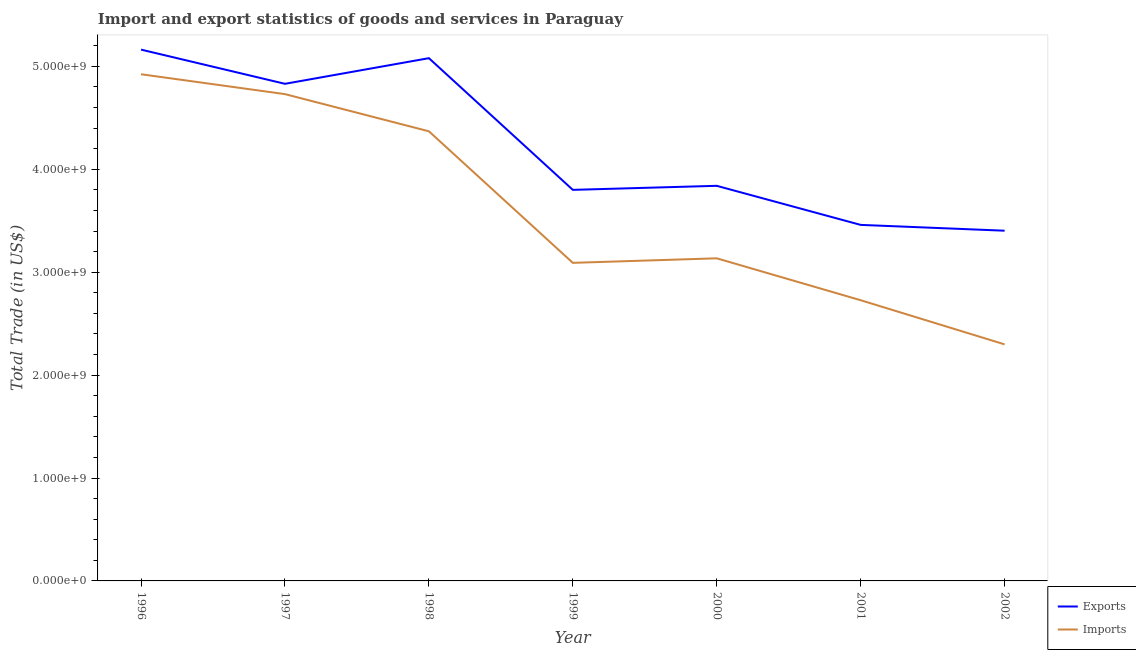How many different coloured lines are there?
Provide a succinct answer. 2. Does the line corresponding to imports of goods and services intersect with the line corresponding to export of goods and services?
Your answer should be compact. No. Is the number of lines equal to the number of legend labels?
Your answer should be compact. Yes. What is the imports of goods and services in 1998?
Offer a terse response. 4.37e+09. Across all years, what is the maximum imports of goods and services?
Make the answer very short. 4.92e+09. Across all years, what is the minimum export of goods and services?
Provide a succinct answer. 3.40e+09. In which year was the imports of goods and services maximum?
Your response must be concise. 1996. What is the total export of goods and services in the graph?
Your answer should be very brief. 2.96e+1. What is the difference between the export of goods and services in 1998 and that in 1999?
Your answer should be compact. 1.28e+09. What is the difference between the export of goods and services in 1998 and the imports of goods and services in 2002?
Offer a terse response. 2.78e+09. What is the average imports of goods and services per year?
Your response must be concise. 3.61e+09. In the year 1998, what is the difference between the imports of goods and services and export of goods and services?
Your response must be concise. -7.11e+08. In how many years, is the export of goods and services greater than 2800000000 US$?
Provide a succinct answer. 7. What is the ratio of the export of goods and services in 1999 to that in 2002?
Make the answer very short. 1.12. What is the difference between the highest and the second highest export of goods and services?
Your answer should be very brief. 8.31e+07. What is the difference between the highest and the lowest export of goods and services?
Provide a short and direct response. 1.76e+09. In how many years, is the export of goods and services greater than the average export of goods and services taken over all years?
Give a very brief answer. 3. Is the imports of goods and services strictly greater than the export of goods and services over the years?
Make the answer very short. No. Is the export of goods and services strictly less than the imports of goods and services over the years?
Offer a very short reply. No. How many years are there in the graph?
Offer a very short reply. 7. Does the graph contain any zero values?
Offer a very short reply. No. Does the graph contain grids?
Your answer should be very brief. No. What is the title of the graph?
Make the answer very short. Import and export statistics of goods and services in Paraguay. What is the label or title of the Y-axis?
Your response must be concise. Total Trade (in US$). What is the Total Trade (in US$) in Exports in 1996?
Keep it short and to the point. 5.16e+09. What is the Total Trade (in US$) in Imports in 1996?
Your answer should be very brief. 4.92e+09. What is the Total Trade (in US$) of Exports in 1997?
Offer a very short reply. 4.83e+09. What is the Total Trade (in US$) in Imports in 1997?
Give a very brief answer. 4.73e+09. What is the Total Trade (in US$) in Exports in 1998?
Ensure brevity in your answer.  5.08e+09. What is the Total Trade (in US$) of Imports in 1998?
Provide a succinct answer. 4.37e+09. What is the Total Trade (in US$) in Exports in 1999?
Your answer should be very brief. 3.80e+09. What is the Total Trade (in US$) in Imports in 1999?
Provide a short and direct response. 3.09e+09. What is the Total Trade (in US$) in Exports in 2000?
Offer a very short reply. 3.84e+09. What is the Total Trade (in US$) of Imports in 2000?
Your answer should be compact. 3.13e+09. What is the Total Trade (in US$) of Exports in 2001?
Your answer should be compact. 3.46e+09. What is the Total Trade (in US$) in Imports in 2001?
Offer a very short reply. 2.73e+09. What is the Total Trade (in US$) of Exports in 2002?
Offer a very short reply. 3.40e+09. What is the Total Trade (in US$) of Imports in 2002?
Give a very brief answer. 2.30e+09. Across all years, what is the maximum Total Trade (in US$) of Exports?
Offer a terse response. 5.16e+09. Across all years, what is the maximum Total Trade (in US$) of Imports?
Give a very brief answer. 4.92e+09. Across all years, what is the minimum Total Trade (in US$) of Exports?
Offer a terse response. 3.40e+09. Across all years, what is the minimum Total Trade (in US$) in Imports?
Your answer should be very brief. 2.30e+09. What is the total Total Trade (in US$) of Exports in the graph?
Your answer should be compact. 2.96e+1. What is the total Total Trade (in US$) in Imports in the graph?
Keep it short and to the point. 2.53e+1. What is the difference between the Total Trade (in US$) in Exports in 1996 and that in 1997?
Your answer should be very brief. 3.32e+08. What is the difference between the Total Trade (in US$) in Imports in 1996 and that in 1997?
Give a very brief answer. 1.93e+08. What is the difference between the Total Trade (in US$) in Exports in 1996 and that in 1998?
Offer a terse response. 8.31e+07. What is the difference between the Total Trade (in US$) in Imports in 1996 and that in 1998?
Your response must be concise. 5.54e+08. What is the difference between the Total Trade (in US$) in Exports in 1996 and that in 1999?
Provide a succinct answer. 1.36e+09. What is the difference between the Total Trade (in US$) of Imports in 1996 and that in 1999?
Your answer should be very brief. 1.83e+09. What is the difference between the Total Trade (in US$) of Exports in 1996 and that in 2000?
Keep it short and to the point. 1.32e+09. What is the difference between the Total Trade (in US$) of Imports in 1996 and that in 2000?
Provide a succinct answer. 1.79e+09. What is the difference between the Total Trade (in US$) in Exports in 1996 and that in 2001?
Give a very brief answer. 1.70e+09. What is the difference between the Total Trade (in US$) of Imports in 1996 and that in 2001?
Offer a very short reply. 2.20e+09. What is the difference between the Total Trade (in US$) of Exports in 1996 and that in 2002?
Give a very brief answer. 1.76e+09. What is the difference between the Total Trade (in US$) in Imports in 1996 and that in 2002?
Give a very brief answer. 2.62e+09. What is the difference between the Total Trade (in US$) of Exports in 1997 and that in 1998?
Offer a very short reply. -2.49e+08. What is the difference between the Total Trade (in US$) in Imports in 1997 and that in 1998?
Ensure brevity in your answer.  3.61e+08. What is the difference between the Total Trade (in US$) in Exports in 1997 and that in 1999?
Your answer should be compact. 1.03e+09. What is the difference between the Total Trade (in US$) of Imports in 1997 and that in 1999?
Your response must be concise. 1.64e+09. What is the difference between the Total Trade (in US$) in Exports in 1997 and that in 2000?
Make the answer very short. 9.91e+08. What is the difference between the Total Trade (in US$) in Imports in 1997 and that in 2000?
Your response must be concise. 1.60e+09. What is the difference between the Total Trade (in US$) of Exports in 1997 and that in 2001?
Keep it short and to the point. 1.37e+09. What is the difference between the Total Trade (in US$) of Imports in 1997 and that in 2001?
Make the answer very short. 2.00e+09. What is the difference between the Total Trade (in US$) of Exports in 1997 and that in 2002?
Your answer should be compact. 1.43e+09. What is the difference between the Total Trade (in US$) of Imports in 1997 and that in 2002?
Ensure brevity in your answer.  2.43e+09. What is the difference between the Total Trade (in US$) of Exports in 1998 and that in 1999?
Your response must be concise. 1.28e+09. What is the difference between the Total Trade (in US$) in Imports in 1998 and that in 1999?
Your answer should be very brief. 1.28e+09. What is the difference between the Total Trade (in US$) of Exports in 1998 and that in 2000?
Keep it short and to the point. 1.24e+09. What is the difference between the Total Trade (in US$) of Imports in 1998 and that in 2000?
Keep it short and to the point. 1.23e+09. What is the difference between the Total Trade (in US$) of Exports in 1998 and that in 2001?
Offer a terse response. 1.62e+09. What is the difference between the Total Trade (in US$) of Imports in 1998 and that in 2001?
Offer a very short reply. 1.64e+09. What is the difference between the Total Trade (in US$) in Exports in 1998 and that in 2002?
Keep it short and to the point. 1.68e+09. What is the difference between the Total Trade (in US$) in Imports in 1998 and that in 2002?
Offer a terse response. 2.07e+09. What is the difference between the Total Trade (in US$) in Exports in 1999 and that in 2000?
Your response must be concise. -3.92e+07. What is the difference between the Total Trade (in US$) of Imports in 1999 and that in 2000?
Your response must be concise. -4.40e+07. What is the difference between the Total Trade (in US$) of Exports in 1999 and that in 2001?
Offer a terse response. 3.40e+08. What is the difference between the Total Trade (in US$) in Imports in 1999 and that in 2001?
Provide a succinct answer. 3.63e+08. What is the difference between the Total Trade (in US$) of Exports in 1999 and that in 2002?
Make the answer very short. 3.97e+08. What is the difference between the Total Trade (in US$) of Imports in 1999 and that in 2002?
Ensure brevity in your answer.  7.92e+08. What is the difference between the Total Trade (in US$) in Exports in 2000 and that in 2001?
Provide a succinct answer. 3.80e+08. What is the difference between the Total Trade (in US$) in Imports in 2000 and that in 2001?
Provide a succinct answer. 4.07e+08. What is the difference between the Total Trade (in US$) in Exports in 2000 and that in 2002?
Offer a very short reply. 4.36e+08. What is the difference between the Total Trade (in US$) of Imports in 2000 and that in 2002?
Offer a terse response. 8.36e+08. What is the difference between the Total Trade (in US$) of Exports in 2001 and that in 2002?
Provide a succinct answer. 5.65e+07. What is the difference between the Total Trade (in US$) in Imports in 2001 and that in 2002?
Your answer should be very brief. 4.29e+08. What is the difference between the Total Trade (in US$) of Exports in 1996 and the Total Trade (in US$) of Imports in 1997?
Provide a succinct answer. 4.32e+08. What is the difference between the Total Trade (in US$) in Exports in 1996 and the Total Trade (in US$) in Imports in 1998?
Give a very brief answer. 7.94e+08. What is the difference between the Total Trade (in US$) of Exports in 1996 and the Total Trade (in US$) of Imports in 1999?
Keep it short and to the point. 2.07e+09. What is the difference between the Total Trade (in US$) of Exports in 1996 and the Total Trade (in US$) of Imports in 2000?
Your answer should be very brief. 2.03e+09. What is the difference between the Total Trade (in US$) of Exports in 1996 and the Total Trade (in US$) of Imports in 2001?
Offer a very short reply. 2.44e+09. What is the difference between the Total Trade (in US$) in Exports in 1996 and the Total Trade (in US$) in Imports in 2002?
Offer a very short reply. 2.86e+09. What is the difference between the Total Trade (in US$) in Exports in 1997 and the Total Trade (in US$) in Imports in 1998?
Provide a succinct answer. 4.61e+08. What is the difference between the Total Trade (in US$) in Exports in 1997 and the Total Trade (in US$) in Imports in 1999?
Provide a succinct answer. 1.74e+09. What is the difference between the Total Trade (in US$) of Exports in 1997 and the Total Trade (in US$) of Imports in 2000?
Offer a very short reply. 1.70e+09. What is the difference between the Total Trade (in US$) in Exports in 1997 and the Total Trade (in US$) in Imports in 2001?
Offer a terse response. 2.10e+09. What is the difference between the Total Trade (in US$) of Exports in 1997 and the Total Trade (in US$) of Imports in 2002?
Keep it short and to the point. 2.53e+09. What is the difference between the Total Trade (in US$) in Exports in 1998 and the Total Trade (in US$) in Imports in 1999?
Offer a terse response. 1.99e+09. What is the difference between the Total Trade (in US$) of Exports in 1998 and the Total Trade (in US$) of Imports in 2000?
Give a very brief answer. 1.94e+09. What is the difference between the Total Trade (in US$) in Exports in 1998 and the Total Trade (in US$) in Imports in 2001?
Keep it short and to the point. 2.35e+09. What is the difference between the Total Trade (in US$) of Exports in 1998 and the Total Trade (in US$) of Imports in 2002?
Offer a very short reply. 2.78e+09. What is the difference between the Total Trade (in US$) of Exports in 1999 and the Total Trade (in US$) of Imports in 2000?
Give a very brief answer. 6.65e+08. What is the difference between the Total Trade (in US$) in Exports in 1999 and the Total Trade (in US$) in Imports in 2001?
Ensure brevity in your answer.  1.07e+09. What is the difference between the Total Trade (in US$) of Exports in 1999 and the Total Trade (in US$) of Imports in 2002?
Ensure brevity in your answer.  1.50e+09. What is the difference between the Total Trade (in US$) in Exports in 2000 and the Total Trade (in US$) in Imports in 2001?
Your answer should be very brief. 1.11e+09. What is the difference between the Total Trade (in US$) of Exports in 2000 and the Total Trade (in US$) of Imports in 2002?
Offer a very short reply. 1.54e+09. What is the difference between the Total Trade (in US$) in Exports in 2001 and the Total Trade (in US$) in Imports in 2002?
Offer a terse response. 1.16e+09. What is the average Total Trade (in US$) of Exports per year?
Your response must be concise. 4.22e+09. What is the average Total Trade (in US$) of Imports per year?
Offer a terse response. 3.61e+09. In the year 1996, what is the difference between the Total Trade (in US$) in Exports and Total Trade (in US$) in Imports?
Provide a short and direct response. 2.39e+08. In the year 1997, what is the difference between the Total Trade (in US$) in Exports and Total Trade (in US$) in Imports?
Ensure brevity in your answer.  1.00e+08. In the year 1998, what is the difference between the Total Trade (in US$) of Exports and Total Trade (in US$) of Imports?
Your answer should be very brief. 7.11e+08. In the year 1999, what is the difference between the Total Trade (in US$) in Exports and Total Trade (in US$) in Imports?
Offer a terse response. 7.09e+08. In the year 2000, what is the difference between the Total Trade (in US$) in Exports and Total Trade (in US$) in Imports?
Give a very brief answer. 7.04e+08. In the year 2001, what is the difference between the Total Trade (in US$) of Exports and Total Trade (in US$) of Imports?
Your answer should be compact. 7.32e+08. In the year 2002, what is the difference between the Total Trade (in US$) in Exports and Total Trade (in US$) in Imports?
Ensure brevity in your answer.  1.10e+09. What is the ratio of the Total Trade (in US$) of Exports in 1996 to that in 1997?
Your answer should be very brief. 1.07. What is the ratio of the Total Trade (in US$) of Imports in 1996 to that in 1997?
Your answer should be very brief. 1.04. What is the ratio of the Total Trade (in US$) in Exports in 1996 to that in 1998?
Provide a succinct answer. 1.02. What is the ratio of the Total Trade (in US$) of Imports in 1996 to that in 1998?
Your answer should be compact. 1.13. What is the ratio of the Total Trade (in US$) of Exports in 1996 to that in 1999?
Your response must be concise. 1.36. What is the ratio of the Total Trade (in US$) of Imports in 1996 to that in 1999?
Your answer should be compact. 1.59. What is the ratio of the Total Trade (in US$) in Exports in 1996 to that in 2000?
Ensure brevity in your answer.  1.34. What is the ratio of the Total Trade (in US$) in Imports in 1996 to that in 2000?
Your answer should be compact. 1.57. What is the ratio of the Total Trade (in US$) in Exports in 1996 to that in 2001?
Keep it short and to the point. 1.49. What is the ratio of the Total Trade (in US$) in Imports in 1996 to that in 2001?
Keep it short and to the point. 1.81. What is the ratio of the Total Trade (in US$) in Exports in 1996 to that in 2002?
Offer a very short reply. 1.52. What is the ratio of the Total Trade (in US$) of Imports in 1996 to that in 2002?
Provide a short and direct response. 2.14. What is the ratio of the Total Trade (in US$) of Exports in 1997 to that in 1998?
Ensure brevity in your answer.  0.95. What is the ratio of the Total Trade (in US$) in Imports in 1997 to that in 1998?
Provide a short and direct response. 1.08. What is the ratio of the Total Trade (in US$) of Exports in 1997 to that in 1999?
Make the answer very short. 1.27. What is the ratio of the Total Trade (in US$) in Imports in 1997 to that in 1999?
Your answer should be compact. 1.53. What is the ratio of the Total Trade (in US$) of Exports in 1997 to that in 2000?
Provide a succinct answer. 1.26. What is the ratio of the Total Trade (in US$) of Imports in 1997 to that in 2000?
Make the answer very short. 1.51. What is the ratio of the Total Trade (in US$) of Exports in 1997 to that in 2001?
Your answer should be very brief. 1.4. What is the ratio of the Total Trade (in US$) of Imports in 1997 to that in 2001?
Keep it short and to the point. 1.73. What is the ratio of the Total Trade (in US$) of Exports in 1997 to that in 2002?
Provide a short and direct response. 1.42. What is the ratio of the Total Trade (in US$) in Imports in 1997 to that in 2002?
Your answer should be compact. 2.06. What is the ratio of the Total Trade (in US$) of Exports in 1998 to that in 1999?
Your response must be concise. 1.34. What is the ratio of the Total Trade (in US$) in Imports in 1998 to that in 1999?
Give a very brief answer. 1.41. What is the ratio of the Total Trade (in US$) in Exports in 1998 to that in 2000?
Offer a very short reply. 1.32. What is the ratio of the Total Trade (in US$) in Imports in 1998 to that in 2000?
Your response must be concise. 1.39. What is the ratio of the Total Trade (in US$) in Exports in 1998 to that in 2001?
Provide a succinct answer. 1.47. What is the ratio of the Total Trade (in US$) in Imports in 1998 to that in 2001?
Offer a terse response. 1.6. What is the ratio of the Total Trade (in US$) in Exports in 1998 to that in 2002?
Offer a very short reply. 1.49. What is the ratio of the Total Trade (in US$) of Imports in 1998 to that in 2002?
Provide a succinct answer. 1.9. What is the ratio of the Total Trade (in US$) in Exports in 1999 to that in 2000?
Give a very brief answer. 0.99. What is the ratio of the Total Trade (in US$) of Imports in 1999 to that in 2000?
Provide a short and direct response. 0.99. What is the ratio of the Total Trade (in US$) in Exports in 1999 to that in 2001?
Provide a succinct answer. 1.1. What is the ratio of the Total Trade (in US$) of Imports in 1999 to that in 2001?
Offer a terse response. 1.13. What is the ratio of the Total Trade (in US$) in Exports in 1999 to that in 2002?
Keep it short and to the point. 1.12. What is the ratio of the Total Trade (in US$) of Imports in 1999 to that in 2002?
Provide a short and direct response. 1.34. What is the ratio of the Total Trade (in US$) in Exports in 2000 to that in 2001?
Your answer should be compact. 1.11. What is the ratio of the Total Trade (in US$) of Imports in 2000 to that in 2001?
Offer a very short reply. 1.15. What is the ratio of the Total Trade (in US$) of Exports in 2000 to that in 2002?
Provide a succinct answer. 1.13. What is the ratio of the Total Trade (in US$) in Imports in 2000 to that in 2002?
Ensure brevity in your answer.  1.36. What is the ratio of the Total Trade (in US$) of Exports in 2001 to that in 2002?
Your answer should be compact. 1.02. What is the ratio of the Total Trade (in US$) in Imports in 2001 to that in 2002?
Your response must be concise. 1.19. What is the difference between the highest and the second highest Total Trade (in US$) of Exports?
Your answer should be very brief. 8.31e+07. What is the difference between the highest and the second highest Total Trade (in US$) in Imports?
Give a very brief answer. 1.93e+08. What is the difference between the highest and the lowest Total Trade (in US$) in Exports?
Keep it short and to the point. 1.76e+09. What is the difference between the highest and the lowest Total Trade (in US$) of Imports?
Keep it short and to the point. 2.62e+09. 